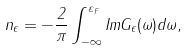Convert formula to latex. <formula><loc_0><loc_0><loc_500><loc_500>n _ { \epsilon } = - \frac { 2 } { \pi } \int _ { - \infty } ^ { \varepsilon _ { F } } I m G _ { \epsilon } ( \omega ) d \omega ,</formula> 